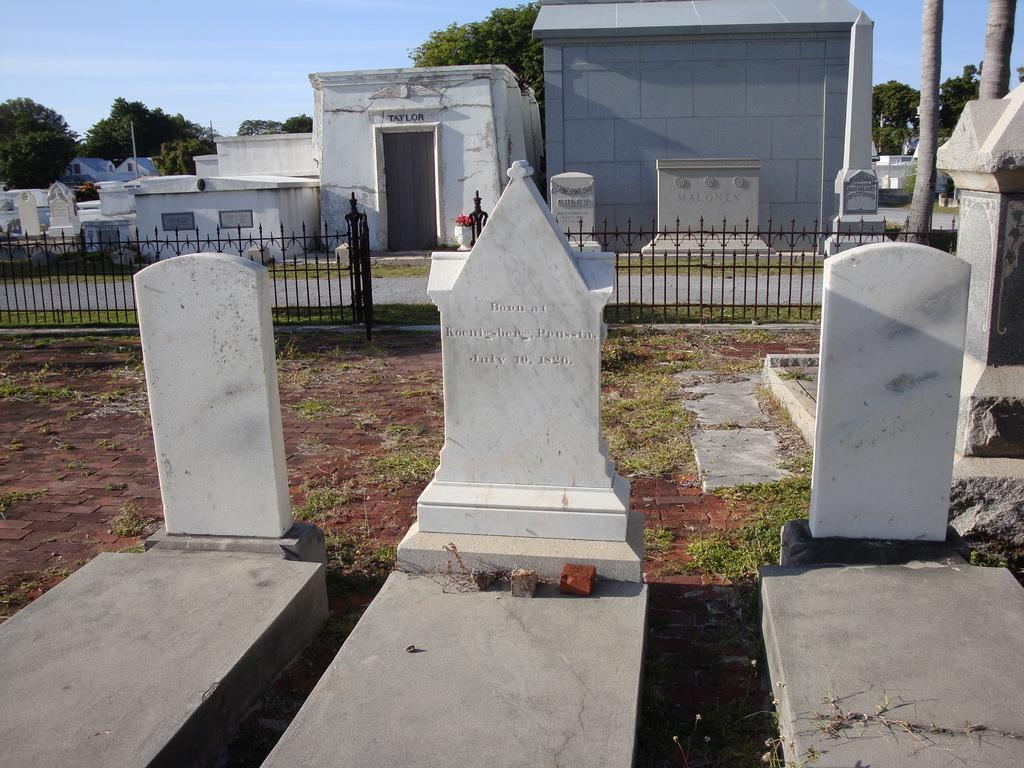Where was the image taken? The image was taken in a graveyard. What can be seen in the center of the image? There are graves in the center of the image. What is visible in the background of the image? There are trees in the background of the image. What type of barrier is present in the image? There is a fencing in the image. Where is the actor playing their role in the image? There is no actor or any indication of a play in the image; it is a photograph of a graveyard with graves, trees, and fencing. 